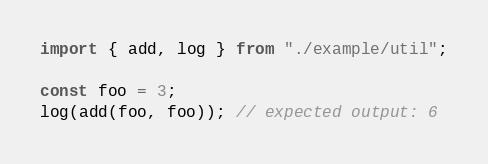<code> <loc_0><loc_0><loc_500><loc_500><_JavaScript_>import { add, log } from "./example/util";

const foo = 3;
log(add(foo, foo)); // expected output: 6
</code> 